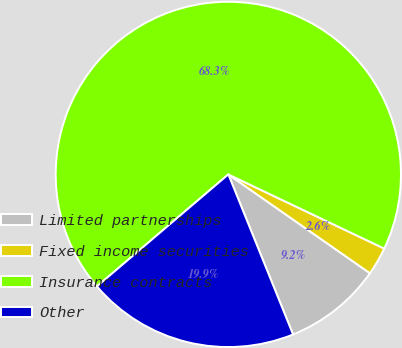<chart> <loc_0><loc_0><loc_500><loc_500><pie_chart><fcel>Limited partnerships<fcel>Fixed income securities<fcel>Insurance contracts<fcel>Other<nl><fcel>9.19%<fcel>2.63%<fcel>68.3%<fcel>19.88%<nl></chart> 